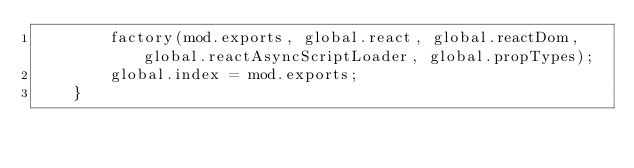Convert code to text. <code><loc_0><loc_0><loc_500><loc_500><_JavaScript_>        factory(mod.exports, global.react, global.reactDom, global.reactAsyncScriptLoader, global.propTypes);
        global.index = mod.exports;
    }</code> 